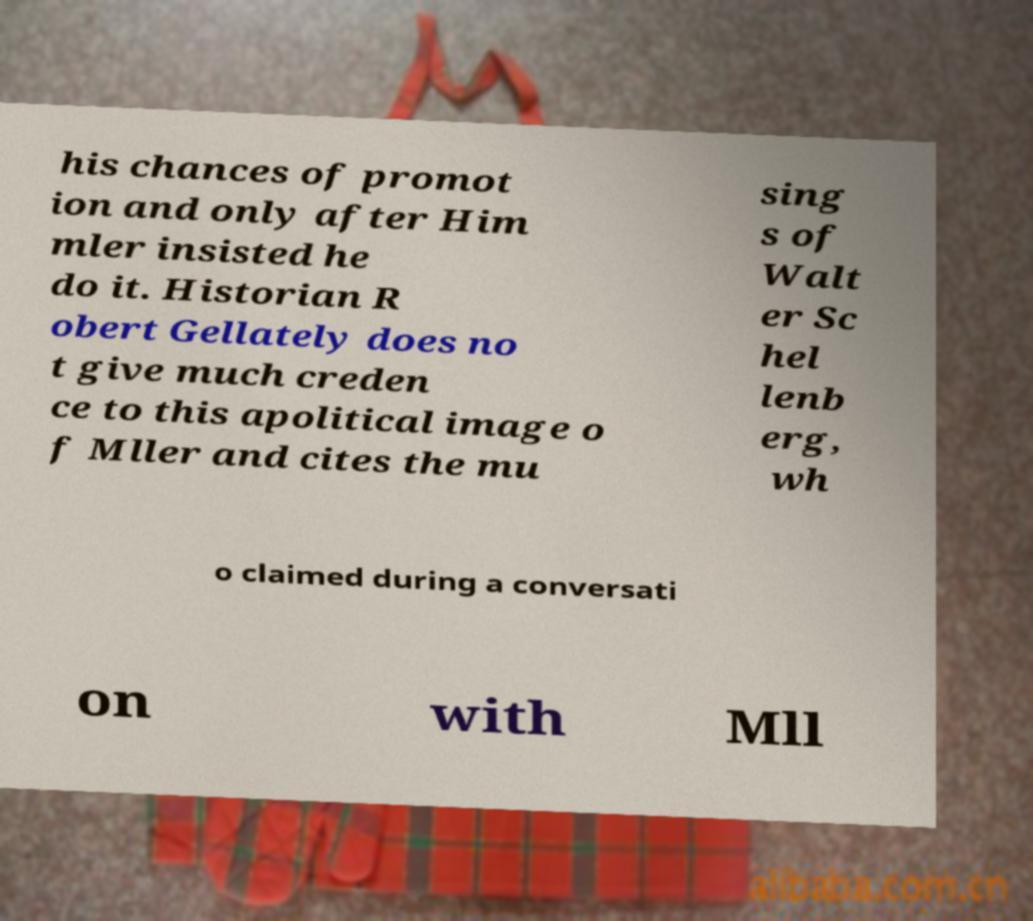What messages or text are displayed in this image? I need them in a readable, typed format. his chances of promot ion and only after Him mler insisted he do it. Historian R obert Gellately does no t give much creden ce to this apolitical image o f Mller and cites the mu sing s of Walt er Sc hel lenb erg, wh o claimed during a conversati on with Mll 